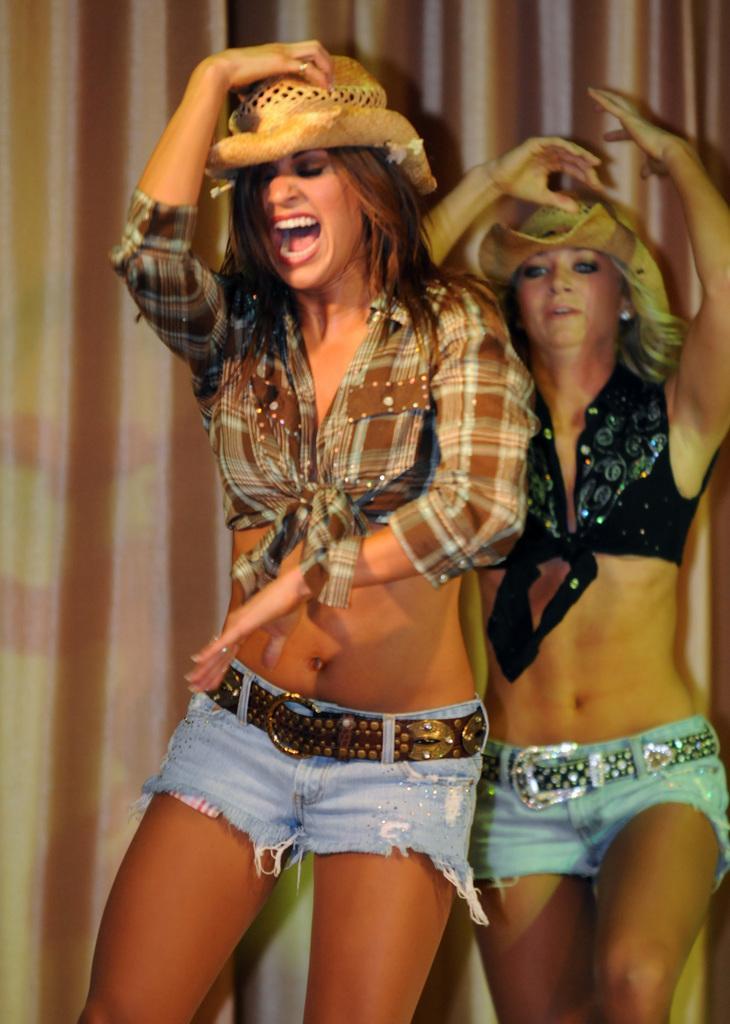How would you summarize this image in a sentence or two? In the picture I can see two women are standing. These women are wearing hats, shorts and some other type of clothes. In the background I can see curtains. 